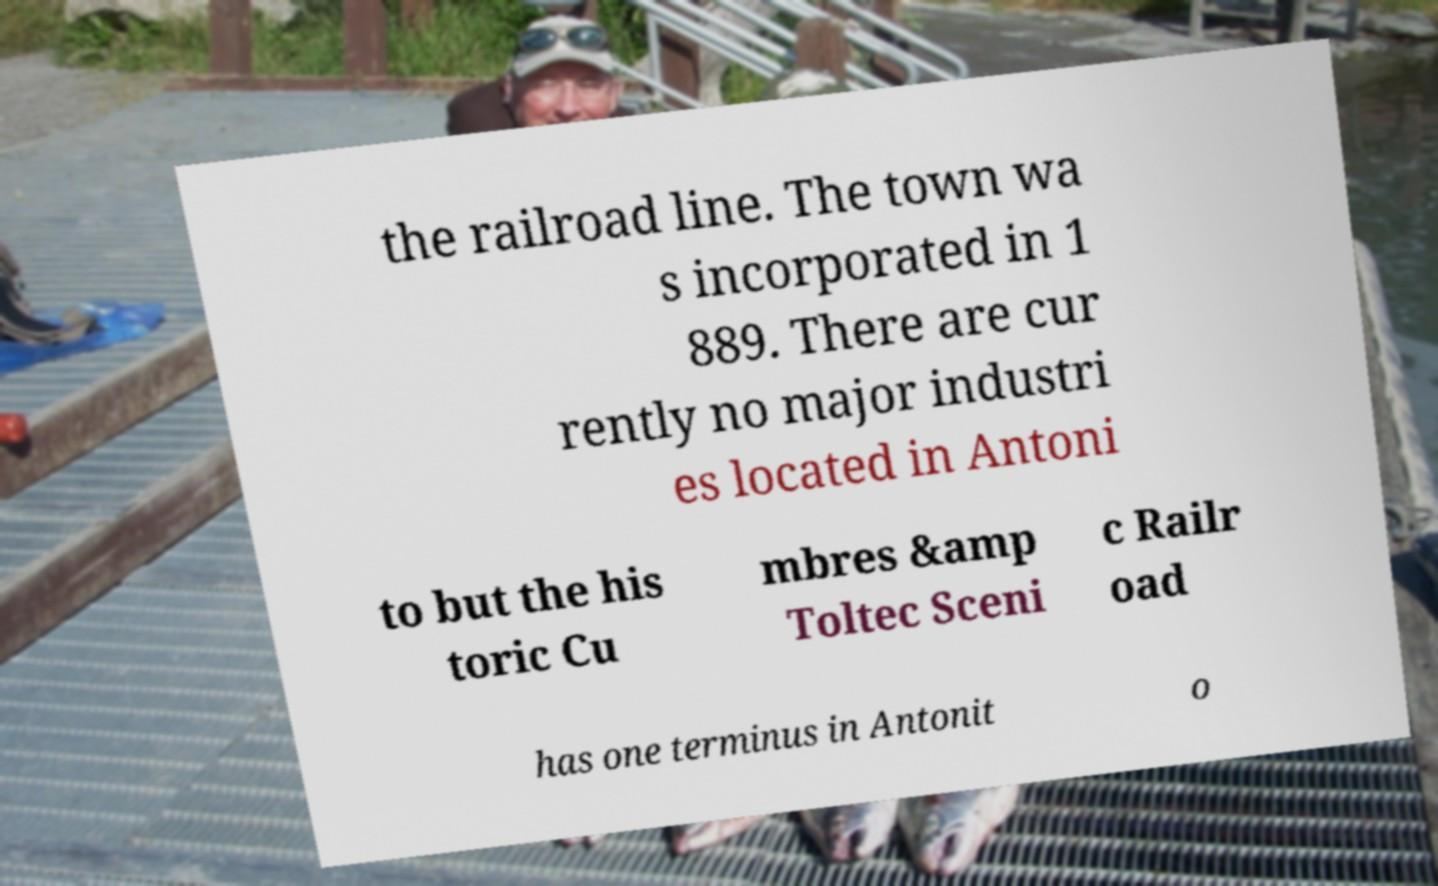Could you assist in decoding the text presented in this image and type it out clearly? the railroad line. The town wa s incorporated in 1 889. There are cur rently no major industri es located in Antoni to but the his toric Cu mbres &amp Toltec Sceni c Railr oad has one terminus in Antonit o 